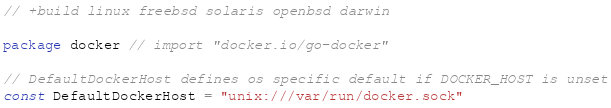<code> <loc_0><loc_0><loc_500><loc_500><_Go_>// +build linux freebsd solaris openbsd darwin

package docker // import "docker.io/go-docker"

// DefaultDockerHost defines os specific default if DOCKER_HOST is unset
const DefaultDockerHost = "unix:///var/run/docker.sock"
</code> 